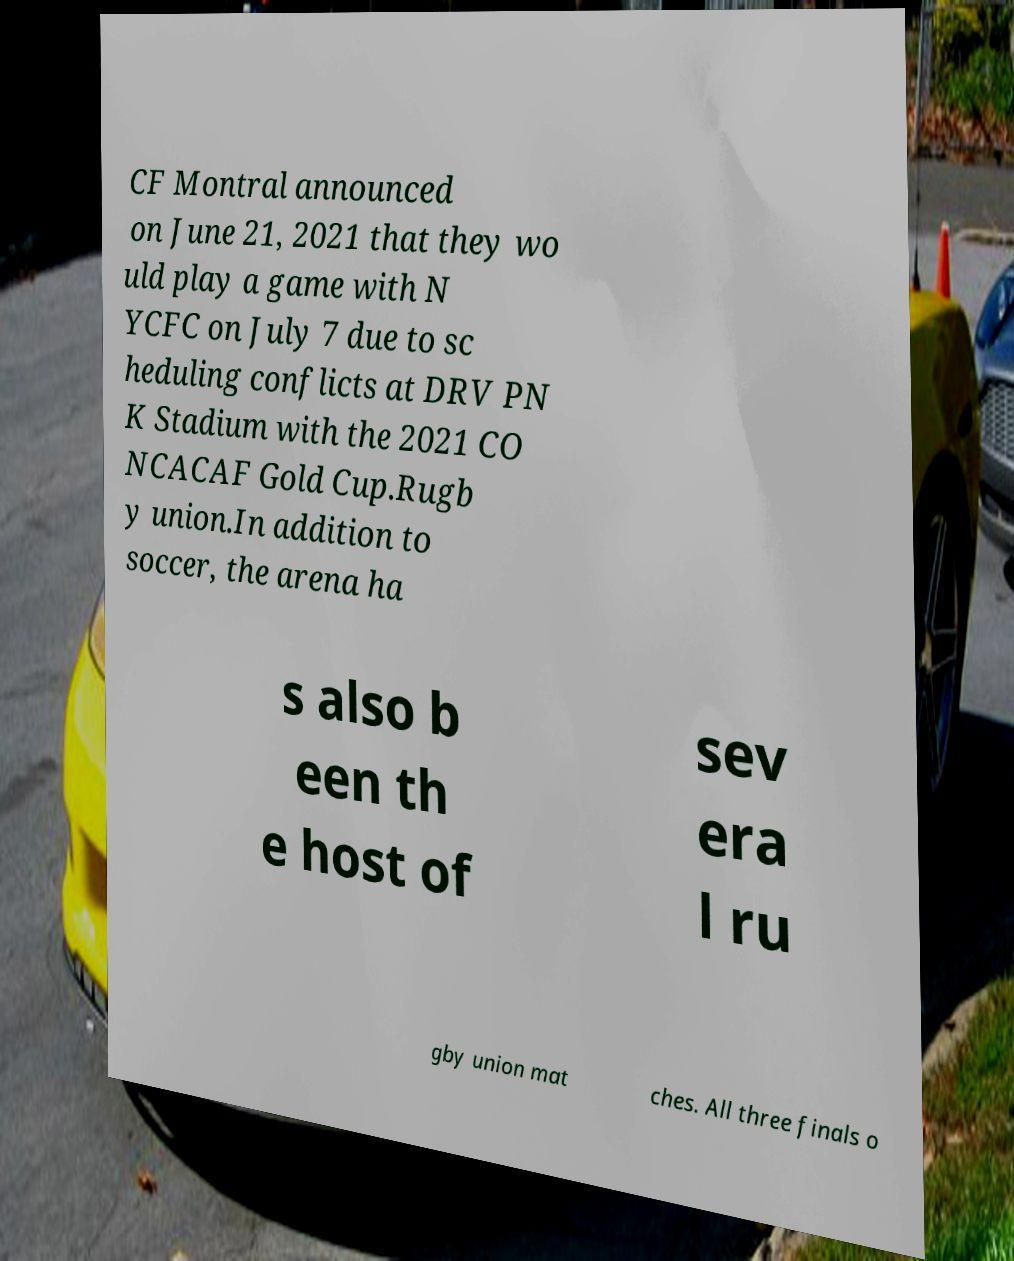Can you read and provide the text displayed in the image?This photo seems to have some interesting text. Can you extract and type it out for me? CF Montral announced on June 21, 2021 that they wo uld play a game with N YCFC on July 7 due to sc heduling conflicts at DRV PN K Stadium with the 2021 CO NCACAF Gold Cup.Rugb y union.In addition to soccer, the arena ha s also b een th e host of sev era l ru gby union mat ches. All three finals o 